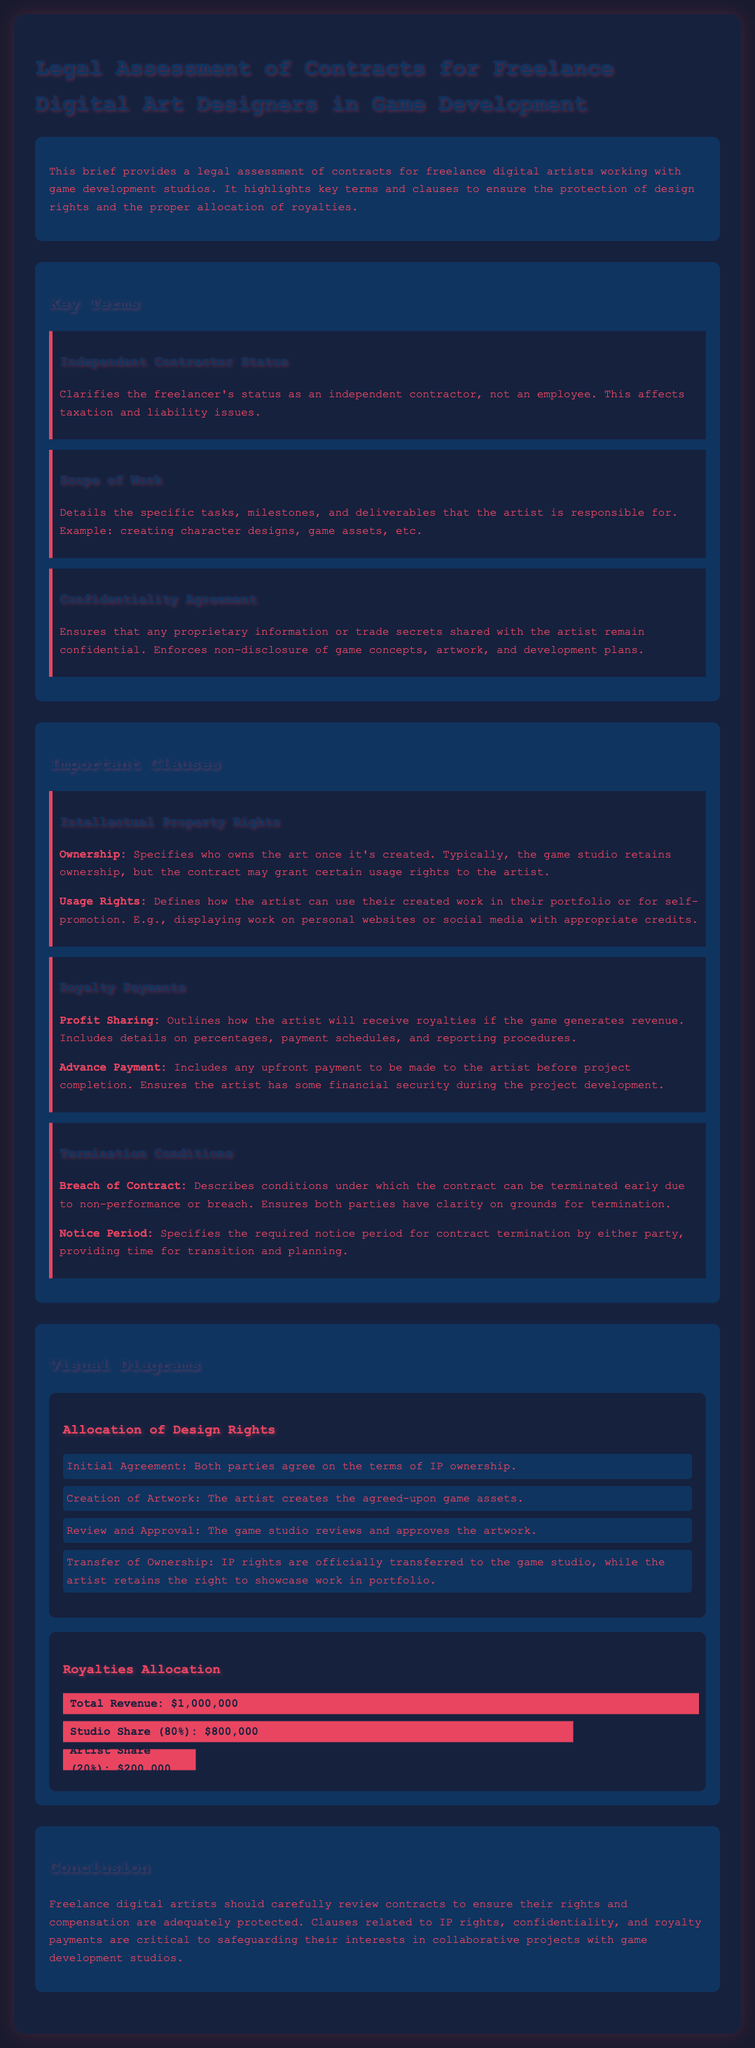what is the legal status of freelancers? The document specifies that freelancers are classified as independent contractors, which affects taxation and liability issues.
Answer: independent contractor what does the scope of work include? The scope of work details the specific tasks, milestones, and deliverables the artist is responsible for, such as creating character designs and game assets.
Answer: character designs, game assets what is the advance payment? The document mentions advance payment as any upfront payment to be made to the artist before project completion.
Answer: upfront payment how much is the studio's share of royalties? According to the royalty allocation, the studio receives 80% of the total revenue generated by the game.
Answer: 80% what rights do artists retain? The document states that artists retain the right to showcase their work in their portfolio after the transfer of ownership.
Answer: showcase work under what condition can the contract be terminated? The contract can be terminated early due to breach of contract or non-performance as specified in the termination conditions.
Answer: breach of contract how much is the artist's share of royalties? The artist's share of royalties is defined as 20% of the total revenue generated by the game.
Answer: 20% what is outlined in the confidentiality agreement? The confidentiality agreement ensures that any proprietary information or trade secrets shared with the artist remain confidential.
Answer: proprietary information what diagram explains royalty allocation? The document has a visual diagram that illustrates how royalties are allocated, detailing the artist's and studio's shares.
Answer: Royalties Allocation 